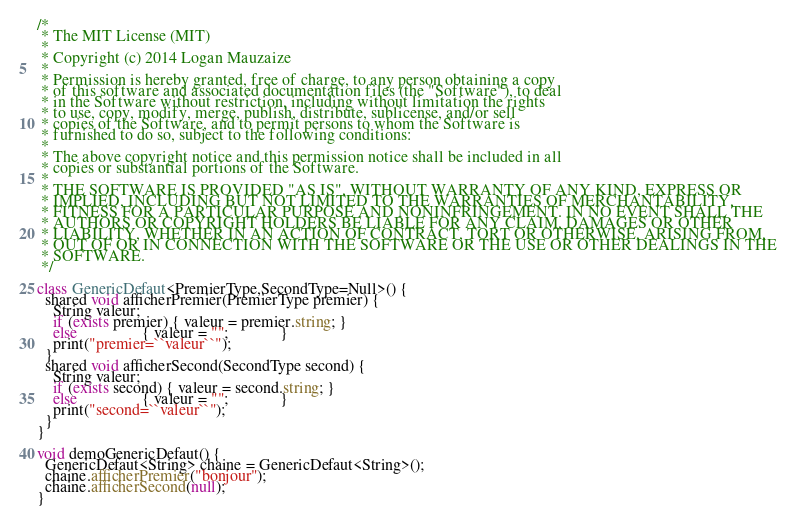Convert code to text. <code><loc_0><loc_0><loc_500><loc_500><_Ceylon_>/*
 * The MIT License (MIT)
 * 
 * Copyright (c) 2014 Logan Mauzaize
 * 
 * Permission is hereby granted, free of charge, to any person obtaining a copy
 * of this software and associated documentation files (the "Software"), to deal
 * in the Software without restriction, including without limitation the rights
 * to use, copy, modify, merge, publish, distribute, sublicense, and/or sell
 * copies of the Software, and to permit persons to whom the Software is
 * furnished to do so, subject to the following conditions:
 *
 * The above copyright notice and this permission notice shall be included in all
 * copies or substantial portions of the Software.
 *
 * THE SOFTWARE IS PROVIDED "AS IS", WITHOUT WARRANTY OF ANY KIND, EXPRESS OR
 * IMPLIED, INCLUDING BUT NOT LIMITED TO THE WARRANTIES OF MERCHANTABILITY,
 * FITNESS FOR A PARTICULAR PURPOSE AND NONINFRINGEMENT. IN NO EVENT SHALL THE
 * AUTHORS OR COPYRIGHT HOLDERS BE LIABLE FOR ANY CLAIM, DAMAGES OR OTHER
 * LIABILITY, WHETHER IN AN ACTION OF CONTRACT, TORT OR OTHERWISE, ARISING FROM,
 * OUT OF OR IN CONNECTION WITH THE SOFTWARE OR THE USE OR OTHER DEALINGS IN THE
 * SOFTWARE.
 */

class GenericDefaut<PremierType,SecondType=Null>() {
  shared void afficherPremier(PremierType premier) {
    String valeur;
    if (exists premier) { valeur = premier.string; }
    else                { valeur = "";             }
    print("premier=``valeur``");
  }
  shared void afficherSecond(SecondType second) {
    String valeur;
    if (exists second) { valeur = second.string; }
    else                { valeur = "";             }
    print("second=``valeur``");
  }
}

void demoGenericDefaut() {
  GenericDefaut<String> chaine = GenericDefaut<String>();
  chaine.afficherPremier("bonjour");
  chaine.afficherSecond(null);
}
</code> 